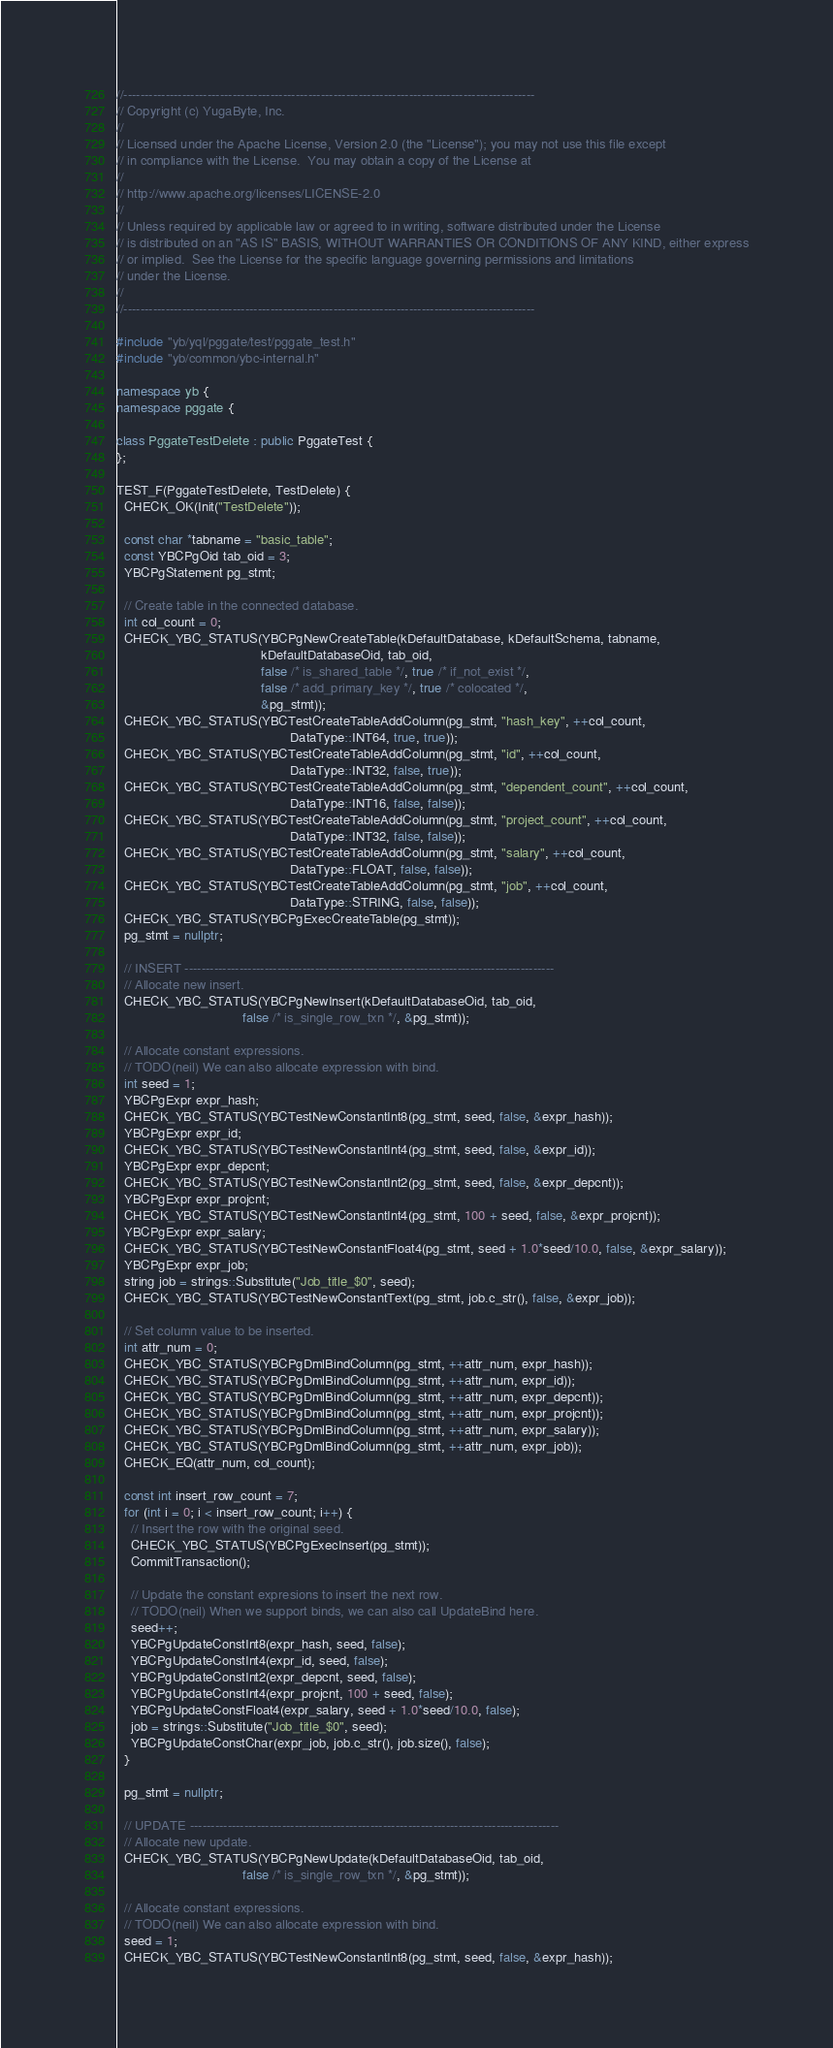<code> <loc_0><loc_0><loc_500><loc_500><_C++_>//--------------------------------------------------------------------------------------------------
// Copyright (c) YugaByte, Inc.
//
// Licensed under the Apache License, Version 2.0 (the "License"); you may not use this file except
// in compliance with the License.  You may obtain a copy of the License at
//
// http://www.apache.org/licenses/LICENSE-2.0
//
// Unless required by applicable law or agreed to in writing, software distributed under the License
// is distributed on an "AS IS" BASIS, WITHOUT WARRANTIES OR CONDITIONS OF ANY KIND, either express
// or implied.  See the License for the specific language governing permissions and limitations
// under the License.
//
//--------------------------------------------------------------------------------------------------

#include "yb/yql/pggate/test/pggate_test.h"
#include "yb/common/ybc-internal.h"

namespace yb {
namespace pggate {

class PggateTestDelete : public PggateTest {
};

TEST_F(PggateTestDelete, TestDelete) {
  CHECK_OK(Init("TestDelete"));

  const char *tabname = "basic_table";
  const YBCPgOid tab_oid = 3;
  YBCPgStatement pg_stmt;

  // Create table in the connected database.
  int col_count = 0;
  CHECK_YBC_STATUS(YBCPgNewCreateTable(kDefaultDatabase, kDefaultSchema, tabname,
                                       kDefaultDatabaseOid, tab_oid,
                                       false /* is_shared_table */, true /* if_not_exist */,
                                       false /* add_primary_key */, true /* colocated */,
                                       &pg_stmt));
  CHECK_YBC_STATUS(YBCTestCreateTableAddColumn(pg_stmt, "hash_key", ++col_count,
                                               DataType::INT64, true, true));
  CHECK_YBC_STATUS(YBCTestCreateTableAddColumn(pg_stmt, "id", ++col_count,
                                               DataType::INT32, false, true));
  CHECK_YBC_STATUS(YBCTestCreateTableAddColumn(pg_stmt, "dependent_count", ++col_count,
                                               DataType::INT16, false, false));
  CHECK_YBC_STATUS(YBCTestCreateTableAddColumn(pg_stmt, "project_count", ++col_count,
                                               DataType::INT32, false, false));
  CHECK_YBC_STATUS(YBCTestCreateTableAddColumn(pg_stmt, "salary", ++col_count,
                                               DataType::FLOAT, false, false));
  CHECK_YBC_STATUS(YBCTestCreateTableAddColumn(pg_stmt, "job", ++col_count,
                                               DataType::STRING, false, false));
  CHECK_YBC_STATUS(YBCPgExecCreateTable(pg_stmt));
  pg_stmt = nullptr;

  // INSERT ----------------------------------------------------------------------------------------
  // Allocate new insert.
  CHECK_YBC_STATUS(YBCPgNewInsert(kDefaultDatabaseOid, tab_oid,
                                  false /* is_single_row_txn */, &pg_stmt));

  // Allocate constant expressions.
  // TODO(neil) We can also allocate expression with bind.
  int seed = 1;
  YBCPgExpr expr_hash;
  CHECK_YBC_STATUS(YBCTestNewConstantInt8(pg_stmt, seed, false, &expr_hash));
  YBCPgExpr expr_id;
  CHECK_YBC_STATUS(YBCTestNewConstantInt4(pg_stmt, seed, false, &expr_id));
  YBCPgExpr expr_depcnt;
  CHECK_YBC_STATUS(YBCTestNewConstantInt2(pg_stmt, seed, false, &expr_depcnt));
  YBCPgExpr expr_projcnt;
  CHECK_YBC_STATUS(YBCTestNewConstantInt4(pg_stmt, 100 + seed, false, &expr_projcnt));
  YBCPgExpr expr_salary;
  CHECK_YBC_STATUS(YBCTestNewConstantFloat4(pg_stmt, seed + 1.0*seed/10.0, false, &expr_salary));
  YBCPgExpr expr_job;
  string job = strings::Substitute("Job_title_$0", seed);
  CHECK_YBC_STATUS(YBCTestNewConstantText(pg_stmt, job.c_str(), false, &expr_job));

  // Set column value to be inserted.
  int attr_num = 0;
  CHECK_YBC_STATUS(YBCPgDmlBindColumn(pg_stmt, ++attr_num, expr_hash));
  CHECK_YBC_STATUS(YBCPgDmlBindColumn(pg_stmt, ++attr_num, expr_id));
  CHECK_YBC_STATUS(YBCPgDmlBindColumn(pg_stmt, ++attr_num, expr_depcnt));
  CHECK_YBC_STATUS(YBCPgDmlBindColumn(pg_stmt, ++attr_num, expr_projcnt));
  CHECK_YBC_STATUS(YBCPgDmlBindColumn(pg_stmt, ++attr_num, expr_salary));
  CHECK_YBC_STATUS(YBCPgDmlBindColumn(pg_stmt, ++attr_num, expr_job));
  CHECK_EQ(attr_num, col_count);

  const int insert_row_count = 7;
  for (int i = 0; i < insert_row_count; i++) {
    // Insert the row with the original seed.
    CHECK_YBC_STATUS(YBCPgExecInsert(pg_stmt));
    CommitTransaction();

    // Update the constant expresions to insert the next row.
    // TODO(neil) When we support binds, we can also call UpdateBind here.
    seed++;
    YBCPgUpdateConstInt8(expr_hash, seed, false);
    YBCPgUpdateConstInt4(expr_id, seed, false);
    YBCPgUpdateConstInt2(expr_depcnt, seed, false);
    YBCPgUpdateConstInt4(expr_projcnt, 100 + seed, false);
    YBCPgUpdateConstFloat4(expr_salary, seed + 1.0*seed/10.0, false);
    job = strings::Substitute("Job_title_$0", seed);
    YBCPgUpdateConstChar(expr_job, job.c_str(), job.size(), false);
  }

  pg_stmt = nullptr;

  // UPDATE ----------------------------------------------------------------------------------------
  // Allocate new update.
  CHECK_YBC_STATUS(YBCPgNewUpdate(kDefaultDatabaseOid, tab_oid,
                                  false /* is_single_row_txn */, &pg_stmt));

  // Allocate constant expressions.
  // TODO(neil) We can also allocate expression with bind.
  seed = 1;
  CHECK_YBC_STATUS(YBCTestNewConstantInt8(pg_stmt, seed, false, &expr_hash));</code> 